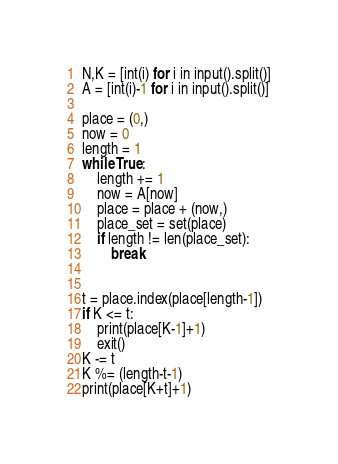<code> <loc_0><loc_0><loc_500><loc_500><_Python_>N,K = [int(i) for i in input().split()]
A = [int(i)-1 for i in input().split()]

place = (0,)
now = 0
length = 1
while True:
    length += 1
    now = A[now]
    place = place + (now,)
    place_set = set(place)
    if length != len(place_set):
        break
    

t = place.index(place[length-1])
if K <= t:
    print(place[K-1]+1)
    exit()
K -= t
K %= (length-t-1)
print(place[K+t]+1)</code> 